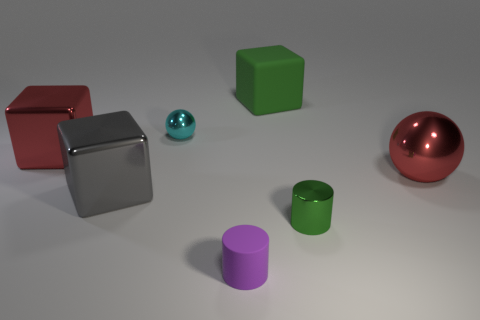Subtract all large red cubes. How many cubes are left? 2 Subtract 1 spheres. How many spheres are left? 1 Subtract all red cubes. How many cubes are left? 2 Add 3 small yellow metallic cubes. How many objects exist? 10 Subtract all red cylinders. Subtract all yellow blocks. How many cylinders are left? 2 Subtract all purple cylinders. How many gray blocks are left? 1 Subtract all balls. How many objects are left? 5 Subtract all large green matte objects. Subtract all tiny cyan shiny spheres. How many objects are left? 5 Add 6 shiny blocks. How many shiny blocks are left? 8 Add 1 cyan metal spheres. How many cyan metal spheres exist? 2 